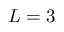Convert formula to latex. <formula><loc_0><loc_0><loc_500><loc_500>L = 3</formula> 